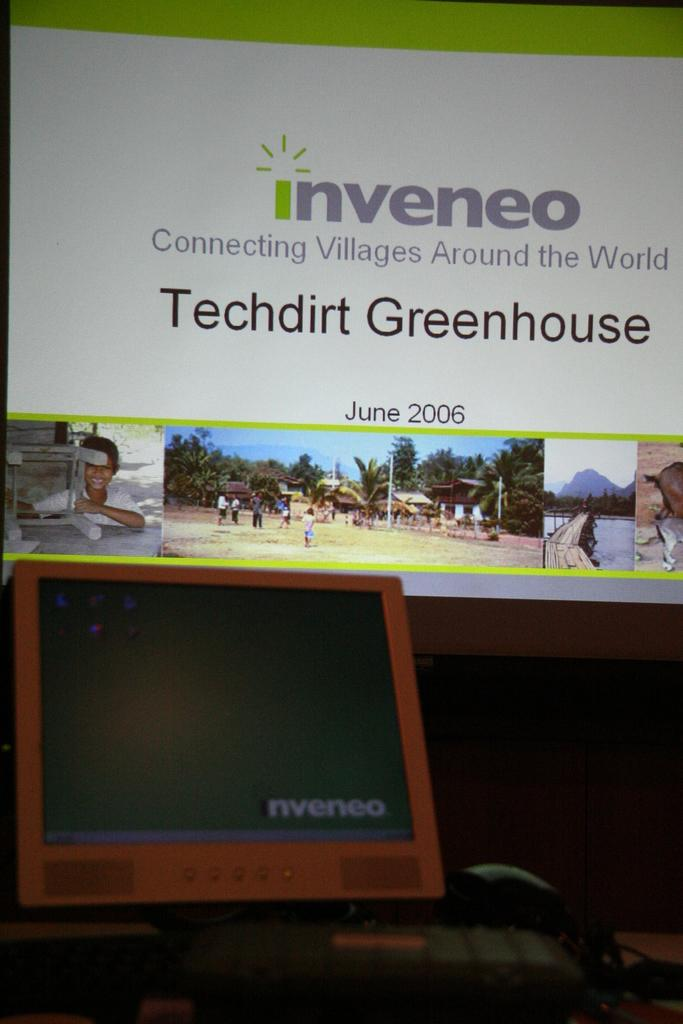<image>
Present a compact description of the photo's key features. An inveneo ad is dated June 2006 and says they connect villages around the world. 